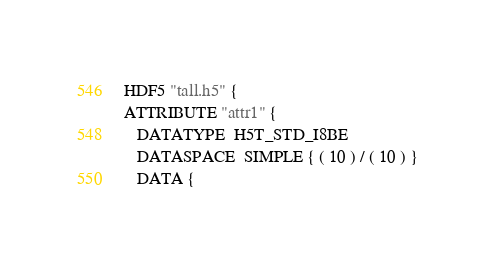Convert code to text. <code><loc_0><loc_0><loc_500><loc_500><_SQL_>HDF5 "tall.h5" {
ATTRIBUTE "attr1" {
   DATATYPE  H5T_STD_I8BE
   DATASPACE  SIMPLE { ( 10 ) / ( 10 ) }
   DATA {</code> 